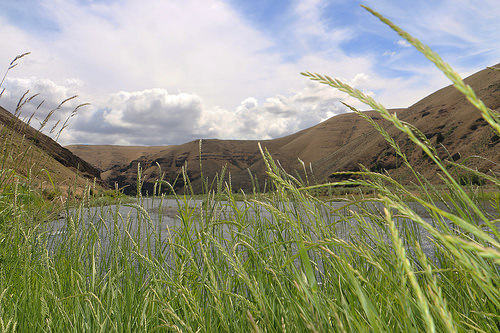<image>
Is there a grasses next to the mountain? No. The grasses is not positioned next to the mountain. They are located in different areas of the scene. 